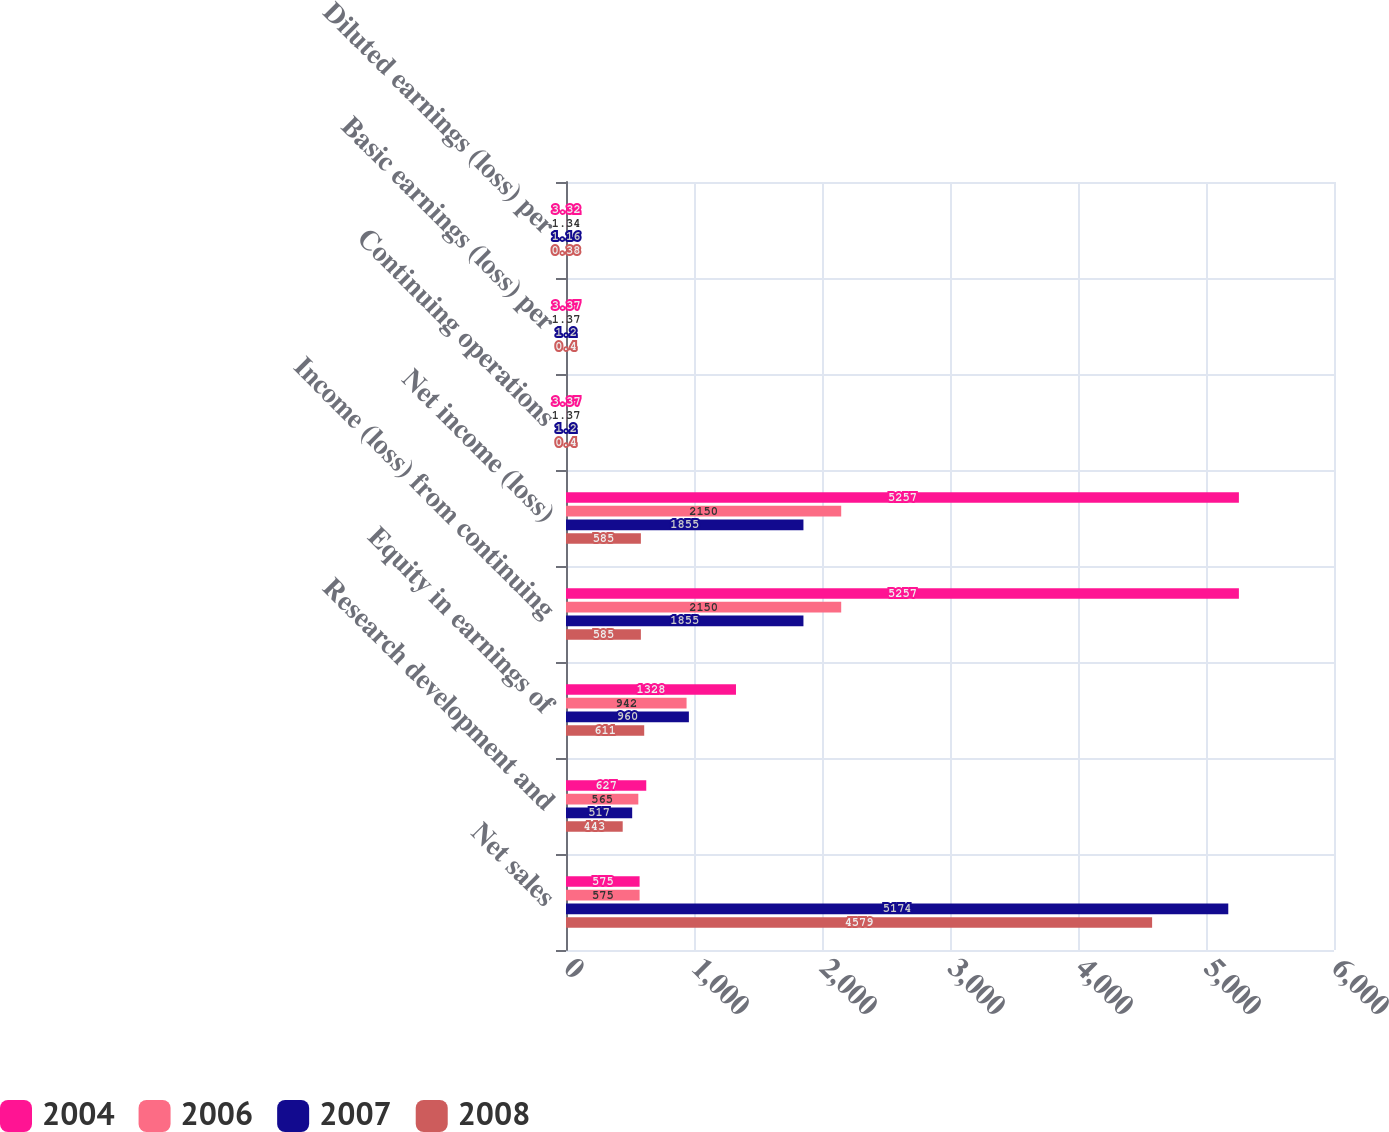Convert chart. <chart><loc_0><loc_0><loc_500><loc_500><stacked_bar_chart><ecel><fcel>Net sales<fcel>Research development and<fcel>Equity in earnings of<fcel>Income (loss) from continuing<fcel>Net income (loss)<fcel>Continuing operations<fcel>Basic earnings (loss) per<fcel>Diluted earnings (loss) per<nl><fcel>2004<fcel>575<fcel>627<fcel>1328<fcel>5257<fcel>5257<fcel>3.37<fcel>3.37<fcel>3.32<nl><fcel>2006<fcel>575<fcel>565<fcel>942<fcel>2150<fcel>2150<fcel>1.37<fcel>1.37<fcel>1.34<nl><fcel>2007<fcel>5174<fcel>517<fcel>960<fcel>1855<fcel>1855<fcel>1.2<fcel>1.2<fcel>1.16<nl><fcel>2008<fcel>4579<fcel>443<fcel>611<fcel>585<fcel>585<fcel>0.4<fcel>0.4<fcel>0.38<nl></chart> 